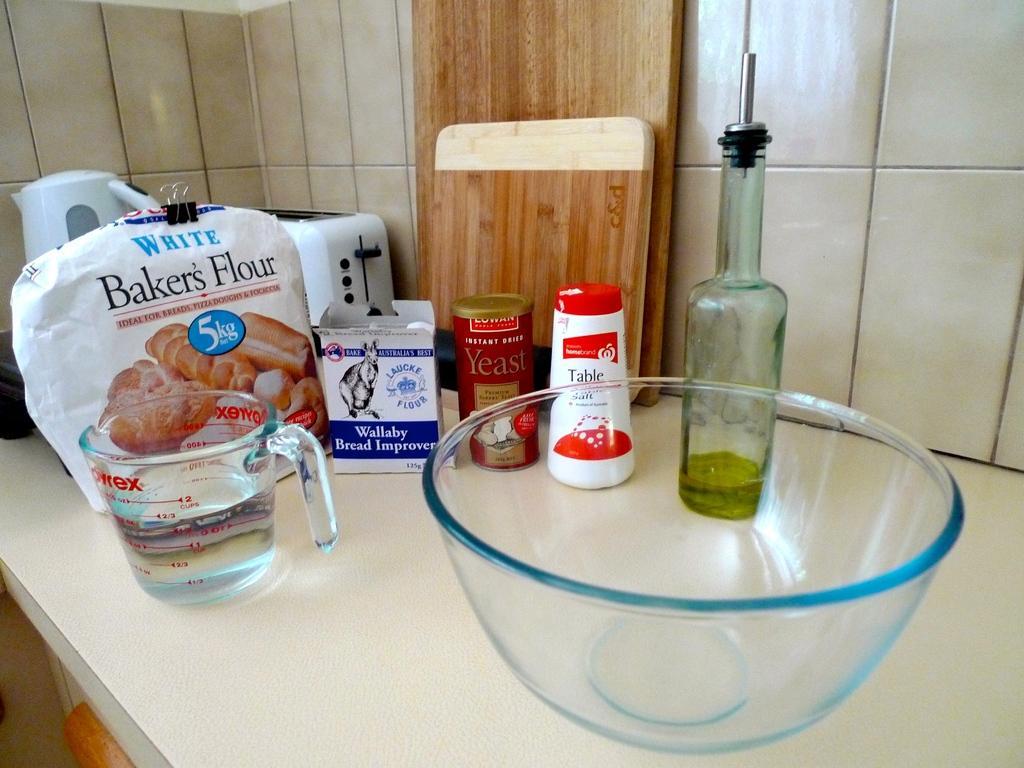Describe this image in one or two sentences. As we can see in the image there is a white color tiles, a table. On table there is a bowl, bottle, yeast bottle, bread improvement box and bakers flour. 